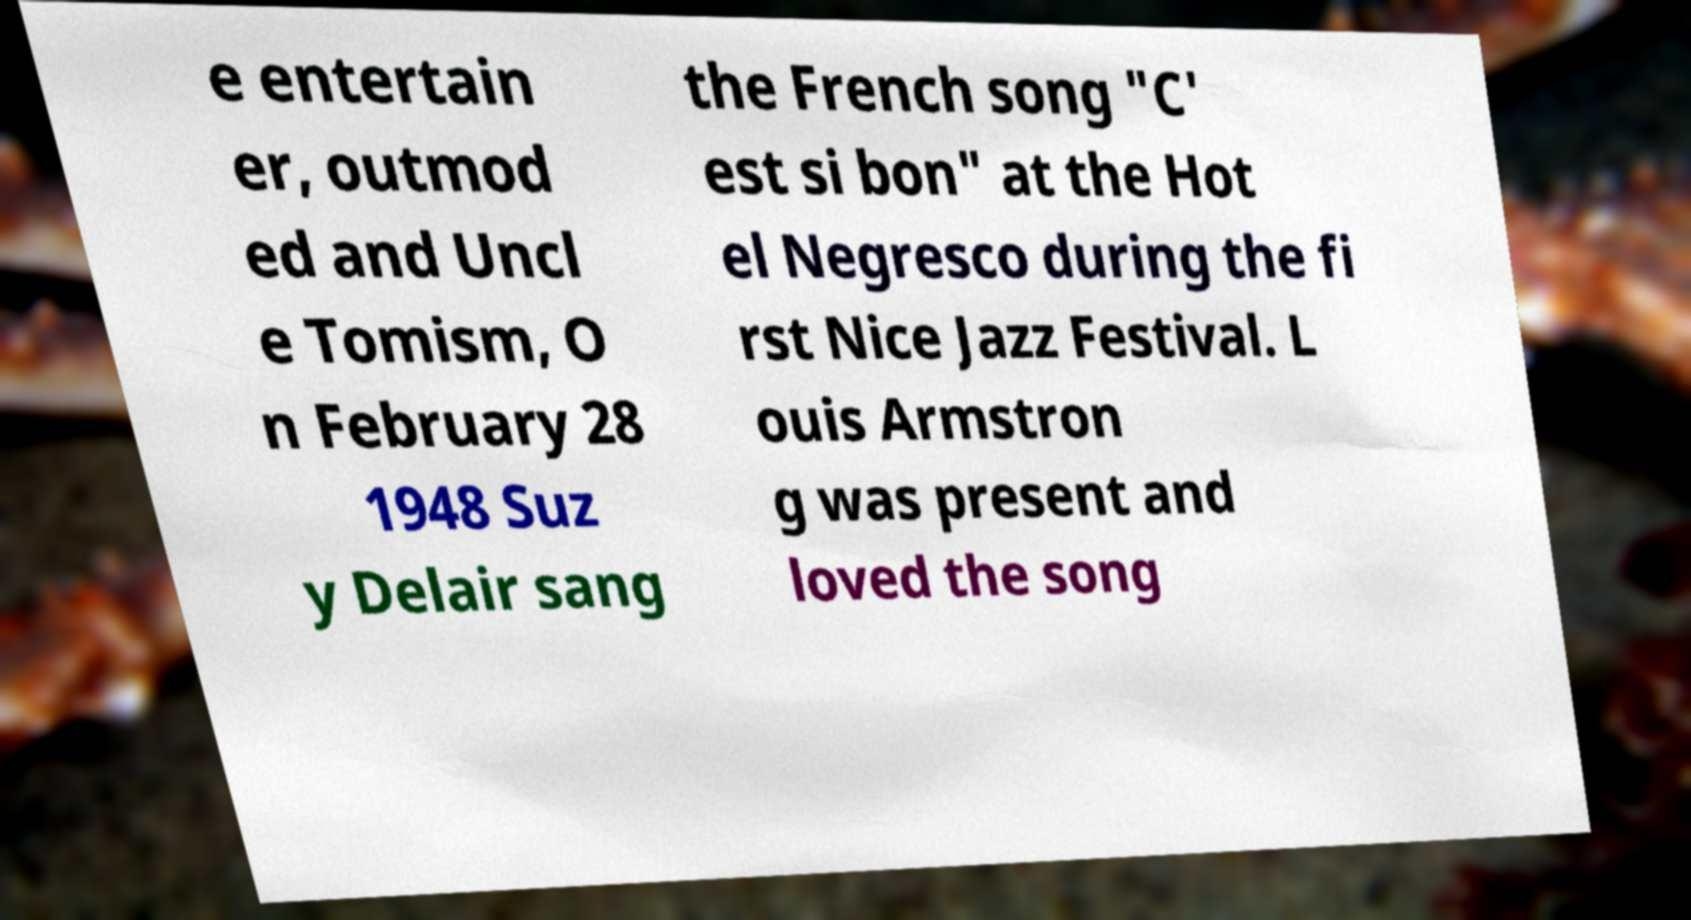Could you extract and type out the text from this image? e entertain er, outmod ed and Uncl e Tomism, O n February 28 1948 Suz y Delair sang the French song "C' est si bon" at the Hot el Negresco during the fi rst Nice Jazz Festival. L ouis Armstron g was present and loved the song 